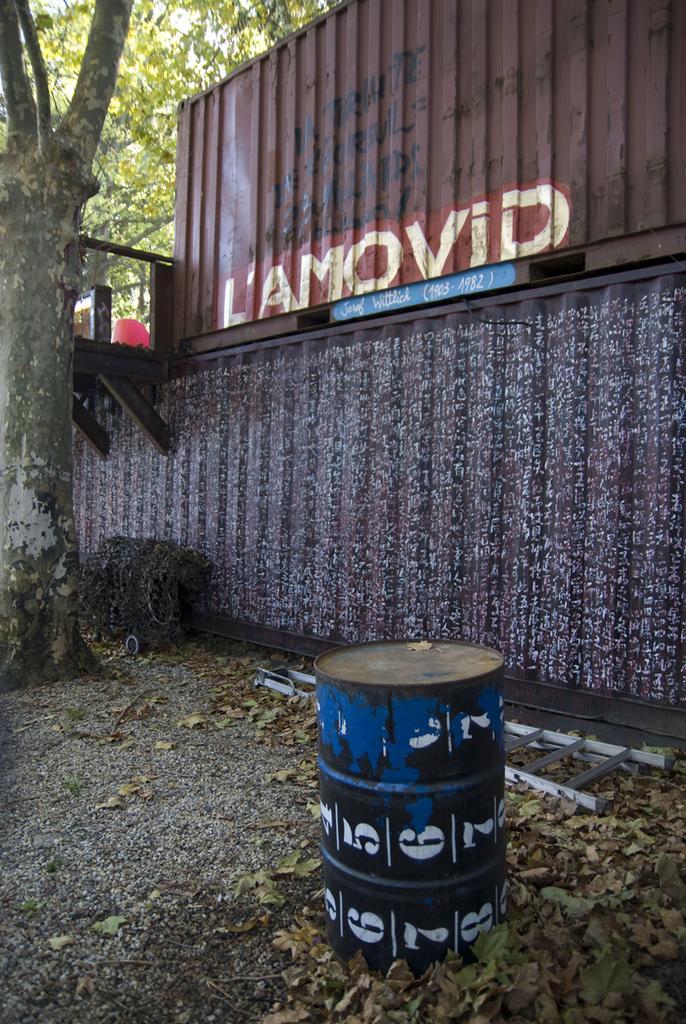Describe this image in one or two sentences. In this image there is a drum on the ground. There are dried leaves on the ground. To the left there is a tree. Behind the tree there is a wall. There is text on the wall. There are numbers painted on the drum. 